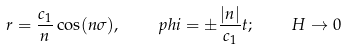<formula> <loc_0><loc_0><loc_500><loc_500>r = \frac { c _ { 1 } } { n } \cos ( n \sigma ) , \quad p h i = \pm \frac { | n | } { c _ { 1 } } t ; \quad H \rightarrow 0</formula> 